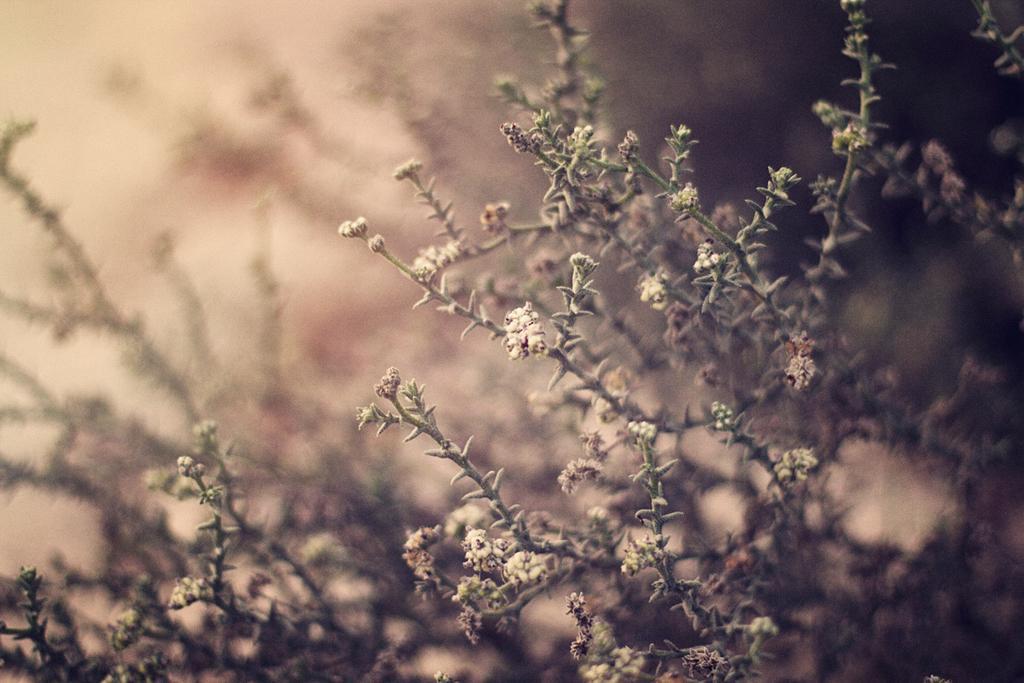Could you give a brief overview of what you see in this image? In this image I can see the flowers. In the background, I can see the plants. 